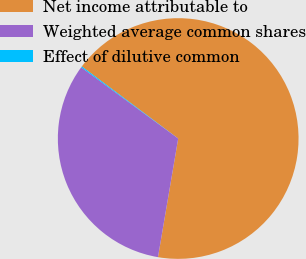Convert chart to OTSL. <chart><loc_0><loc_0><loc_500><loc_500><pie_chart><fcel>Net income attributable to<fcel>Weighted average common shares<fcel>Effect of dilutive common<nl><fcel>67.46%<fcel>32.39%<fcel>0.14%<nl></chart> 